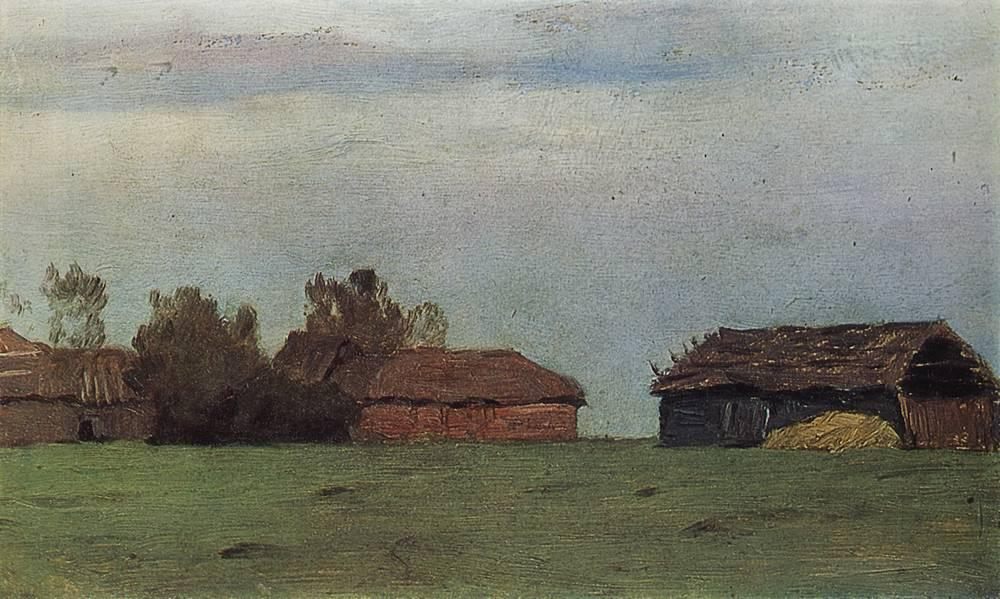Can you tell me more about the history and possible stories behind these buildings? Certainly! The buildings in the painting appear to be old farm structures, possibly barns and sheds that have been abandoned or less frequently used over time. They could have once been bustling with activity, housing livestock and storing grains. The state of disrepair suggests they have witnessed years of changing seasons and weather. Perhaps these buildings were part of a thriving farmstead that has since seen its inhabitants move on. They stand as silent witnesses to the history of rural life, holding untold stories of the people who once worked the land. The sense of history embedded in their weathered walls invites viewers to imagine the past lives and activities that took place here. 